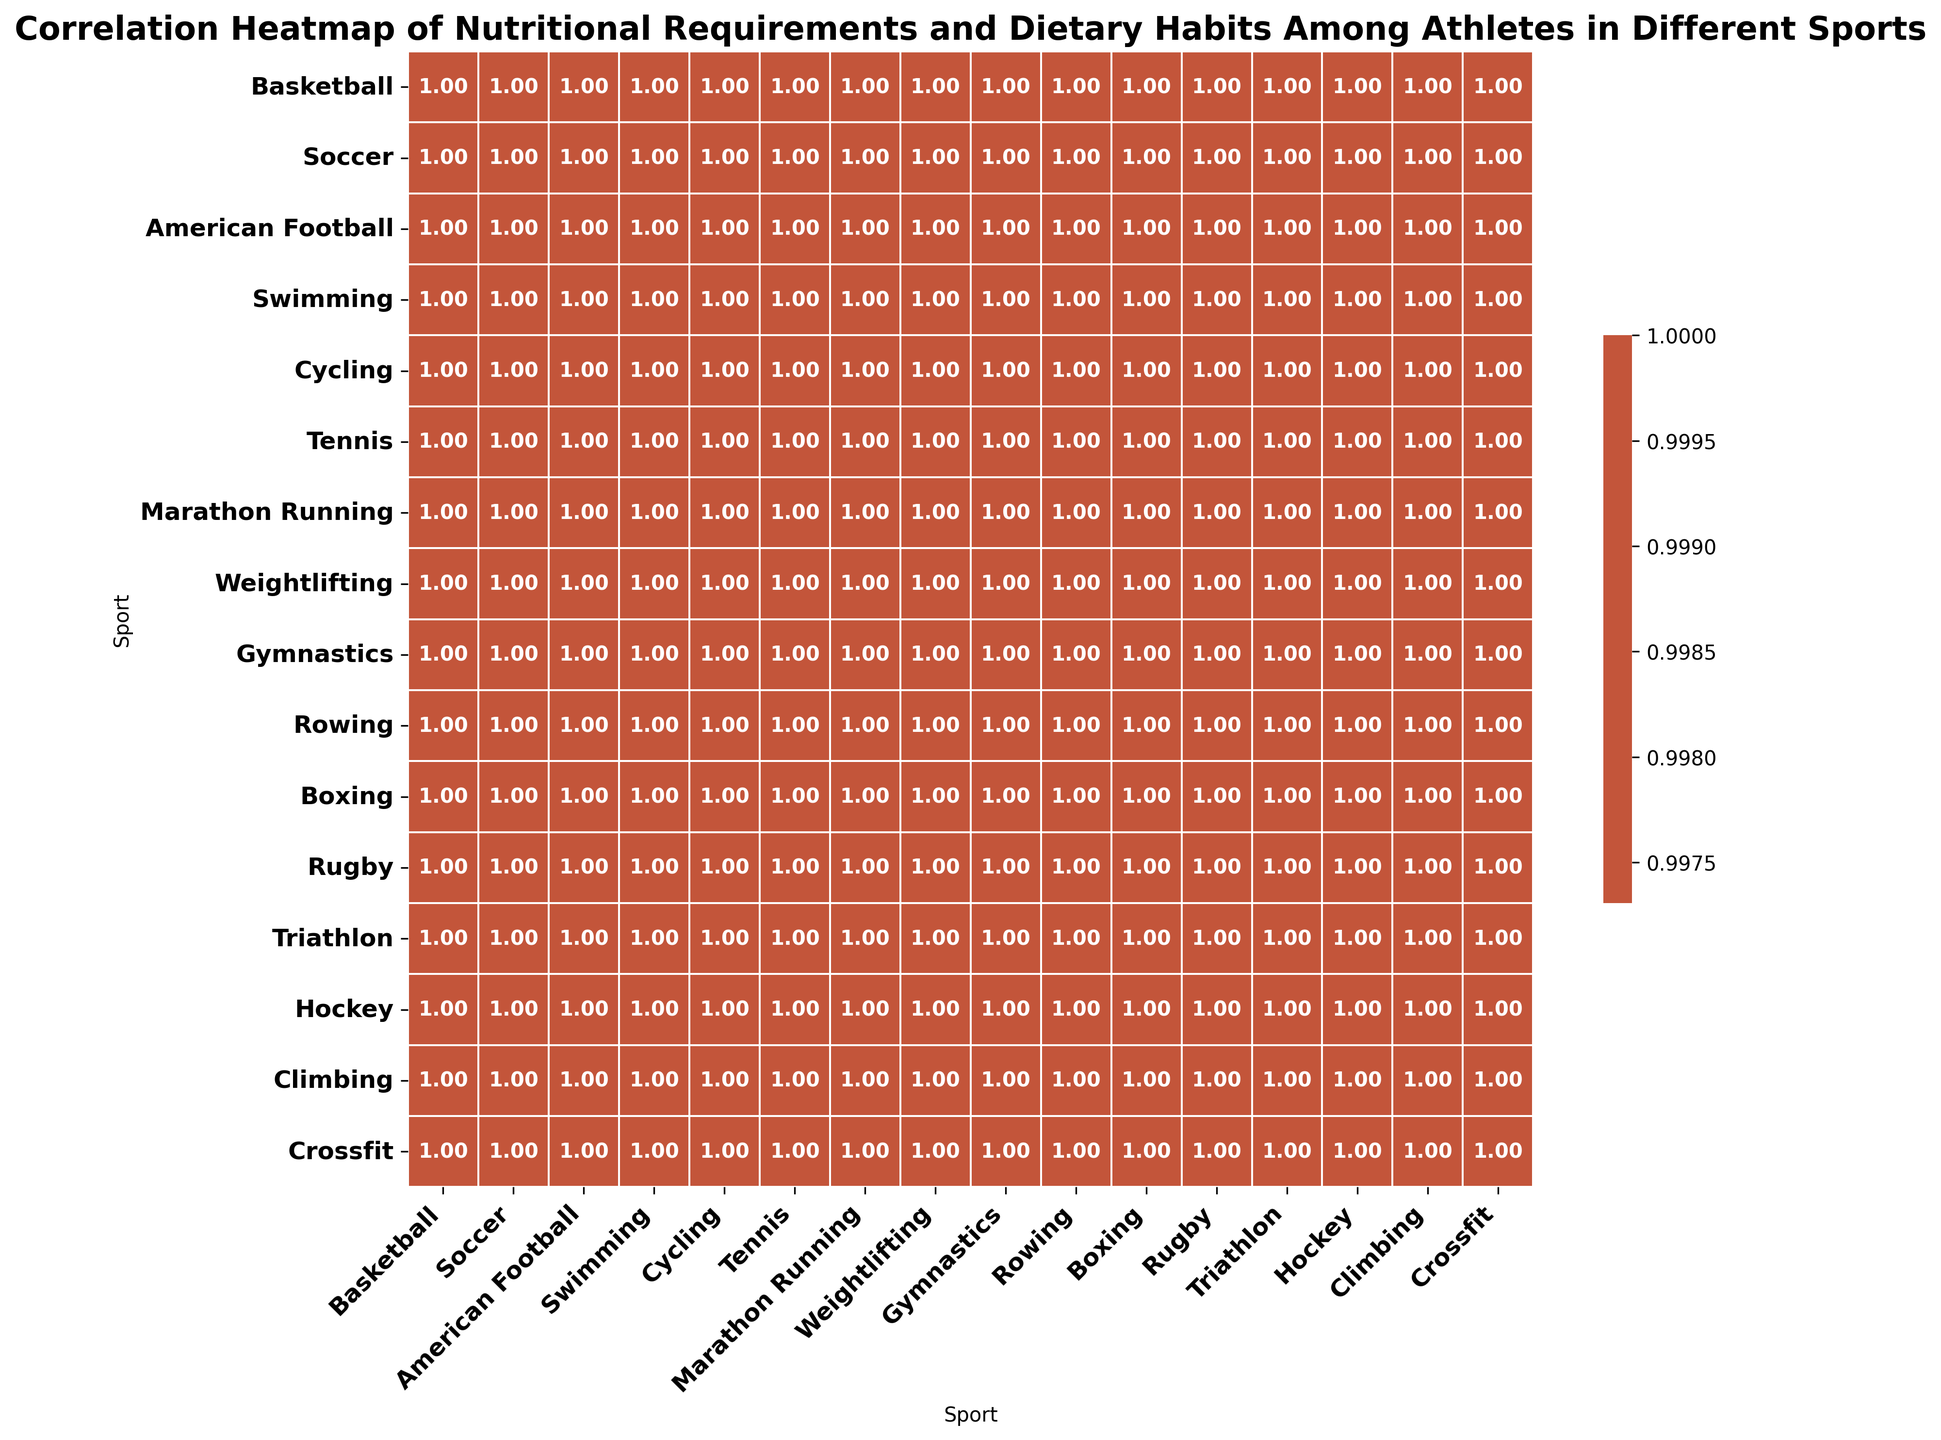What sport has the highest correlation with Triathlon in terms of nutritional requirements? Observing the heatmap, look for the cell in the Triathlon column with the highest positive value. The value closest to 1 represents the highest correlation.
Answer: Marathon Running Which two sports show the lowest correlation in their nutritional requirements? Identify the cell in the heatmap that contains the lowest value, indicating the least correlation, which will be near -1. Note the intersecting sports.
Answer: Weightlifting and Marathon Running Do swimmers and cyclists have a positive or negative nutritional correlation? Find the cell where the Swimmers row intersects with the Cyclists column. Check the value; if it's greater than 0, the correlation is positive; if less than 0, it's negative.
Answer: Positive Which has a stronger correlation with boxing, American Football or Gymnastics? Locate the Boxing column and find the values corresponding to American Football and Gymnastics rows. Compare the two to determine which is higher.
Answer: American Football What is the average of the correlation values between Tennis and all the other sports? Sum all the correlation values in the Tennis column and divide by the number of sports (excluding Tennis itself). Total of values is approximately 9.51 divided by 14 sports.
Answer: 0.68 How does the correlation between Rowing and Rugby compare to that between Rowing and Hockey? Find the correlation values for Rowing with Rugby and Rowing with Hockey in the heatmap, then compare the two values.
Answer: Rowing has a higher correlation with Rugby Which sport has the most negative correlation with Climbing? Look for the minimum value in the Climbing column; the corresponding sport is the one with the most negative correlation.
Answer: Weightlifting Are Soccer and Marathon Running more positively or negatively correlated? Locate the cell where the Soccer row intersects with the Marathon Running column. Identify if the value is positive (>0) or negative (<0).
Answer: Positive What sport shows the closest correlation with Crossfit? Identify the cell in the Crossfit column with the value that is closest to 1 (but not 1, as that would be Crossfit with itself).
Answer: American Football 